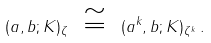<formula> <loc_0><loc_0><loc_500><loc_500>( a , b ; K ) _ { \zeta } \ \cong \ ( a ^ { k } , b ; K ) _ { \zeta ^ { k } } \, .</formula> 